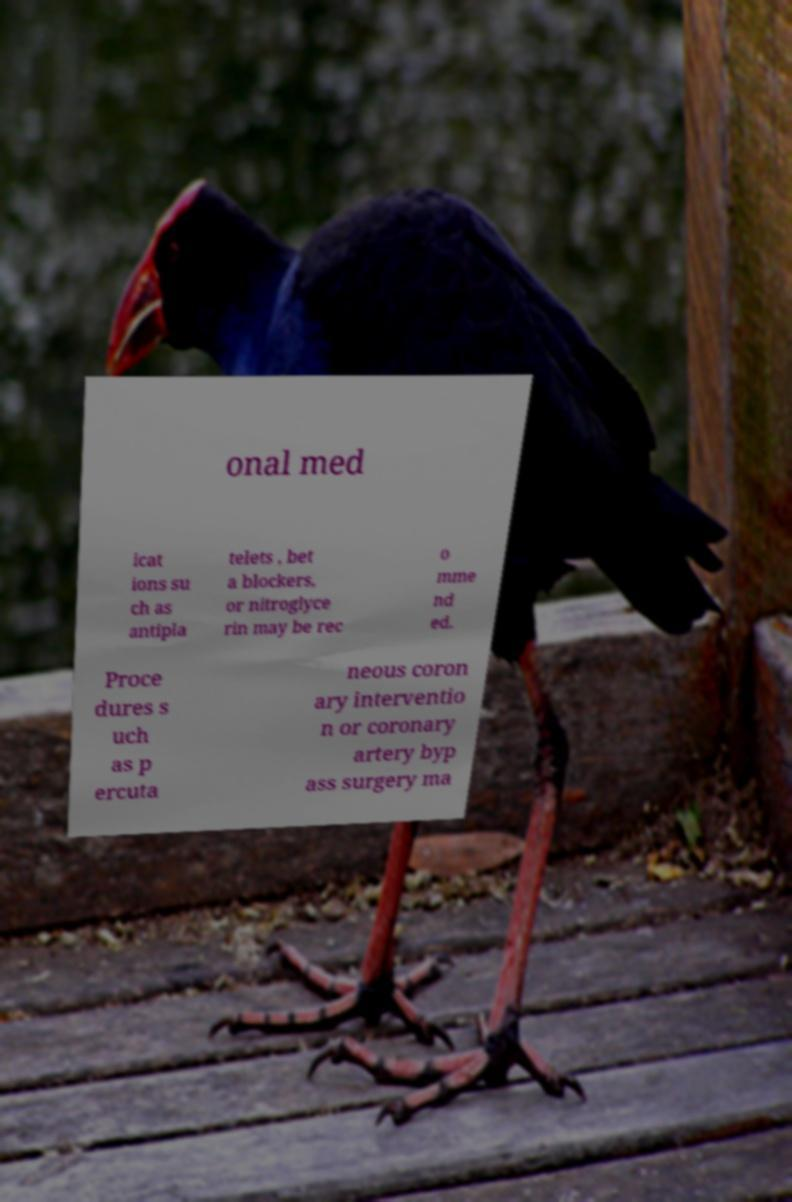For documentation purposes, I need the text within this image transcribed. Could you provide that? onal med icat ions su ch as antipla telets , bet a blockers, or nitroglyce rin may be rec o mme nd ed. Proce dures s uch as p ercuta neous coron ary interventio n or coronary artery byp ass surgery ma 